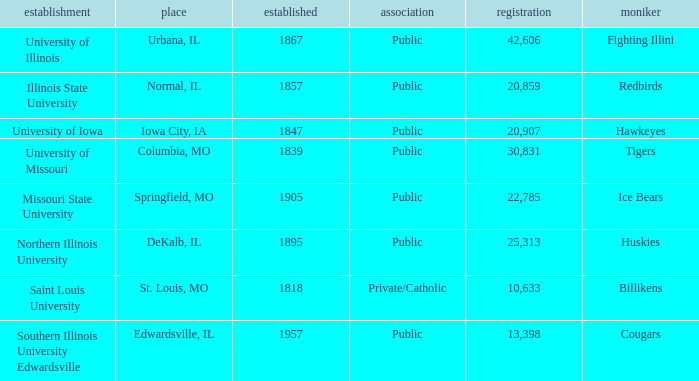Parse the full table. {'header': ['establishment', 'place', 'established', 'association', 'registration', 'moniker'], 'rows': [['University of Illinois', 'Urbana, IL', '1867', 'Public', '42,606', 'Fighting Illini'], ['Illinois State University', 'Normal, IL', '1857', 'Public', '20,859', 'Redbirds'], ['University of Iowa', 'Iowa City, IA', '1847', 'Public', '20,907', 'Hawkeyes'], ['University of Missouri', 'Columbia, MO', '1839', 'Public', '30,831', 'Tigers'], ['Missouri State University', 'Springfield, MO', '1905', 'Public', '22,785', 'Ice Bears'], ['Northern Illinois University', 'DeKalb, IL', '1895', 'Public', '25,313', 'Huskies'], ['Saint Louis University', 'St. Louis, MO', '1818', 'Private/Catholic', '10,633', 'Billikens'], ['Southern Illinois University Edwardsville', 'Edwardsville, IL', '1957', 'Public', '13,398', 'Cougars']]} Which institution is private/catholic? Saint Louis University. 